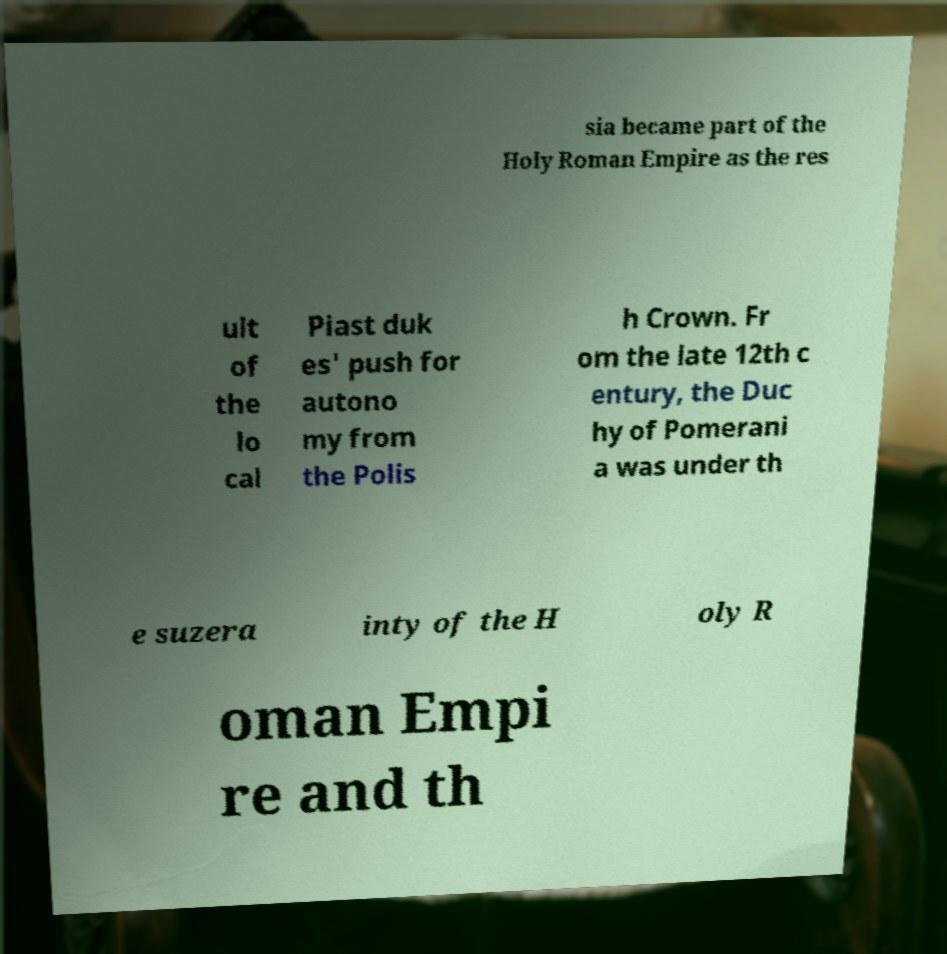What messages or text are displayed in this image? I need them in a readable, typed format. sia became part of the Holy Roman Empire as the res ult of the lo cal Piast duk es' push for autono my from the Polis h Crown. Fr om the late 12th c entury, the Duc hy of Pomerani a was under th e suzera inty of the H oly R oman Empi re and th 